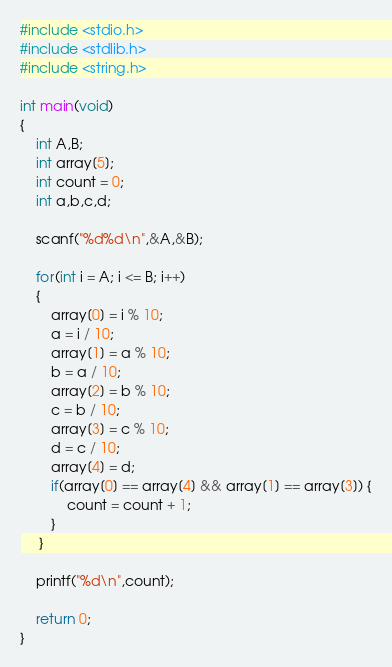Convert code to text. <code><loc_0><loc_0><loc_500><loc_500><_C_>#include <stdio.h>
#include <stdlib.h>
#include <string.h>

int main(void)
{
    int A,B;
    int array[5];
    int count = 0;
    int a,b,c,d;

    scanf("%d%d\n",&A,&B);

    for(int i = A; i <= B; i++)
    {
        array[0] = i % 10;
        a = i / 10;
        array[1] = a % 10;
        b = a / 10;
        array[2] = b % 10;
        c = b / 10;
        array[3] = c % 10;
        d = c / 10;
        array[4] = d;
        if(array[0] == array[4] && array[1] == array[3]) {
            count = count + 1;
        }
     }

    printf("%d\n",count);

    return 0;
}
</code> 